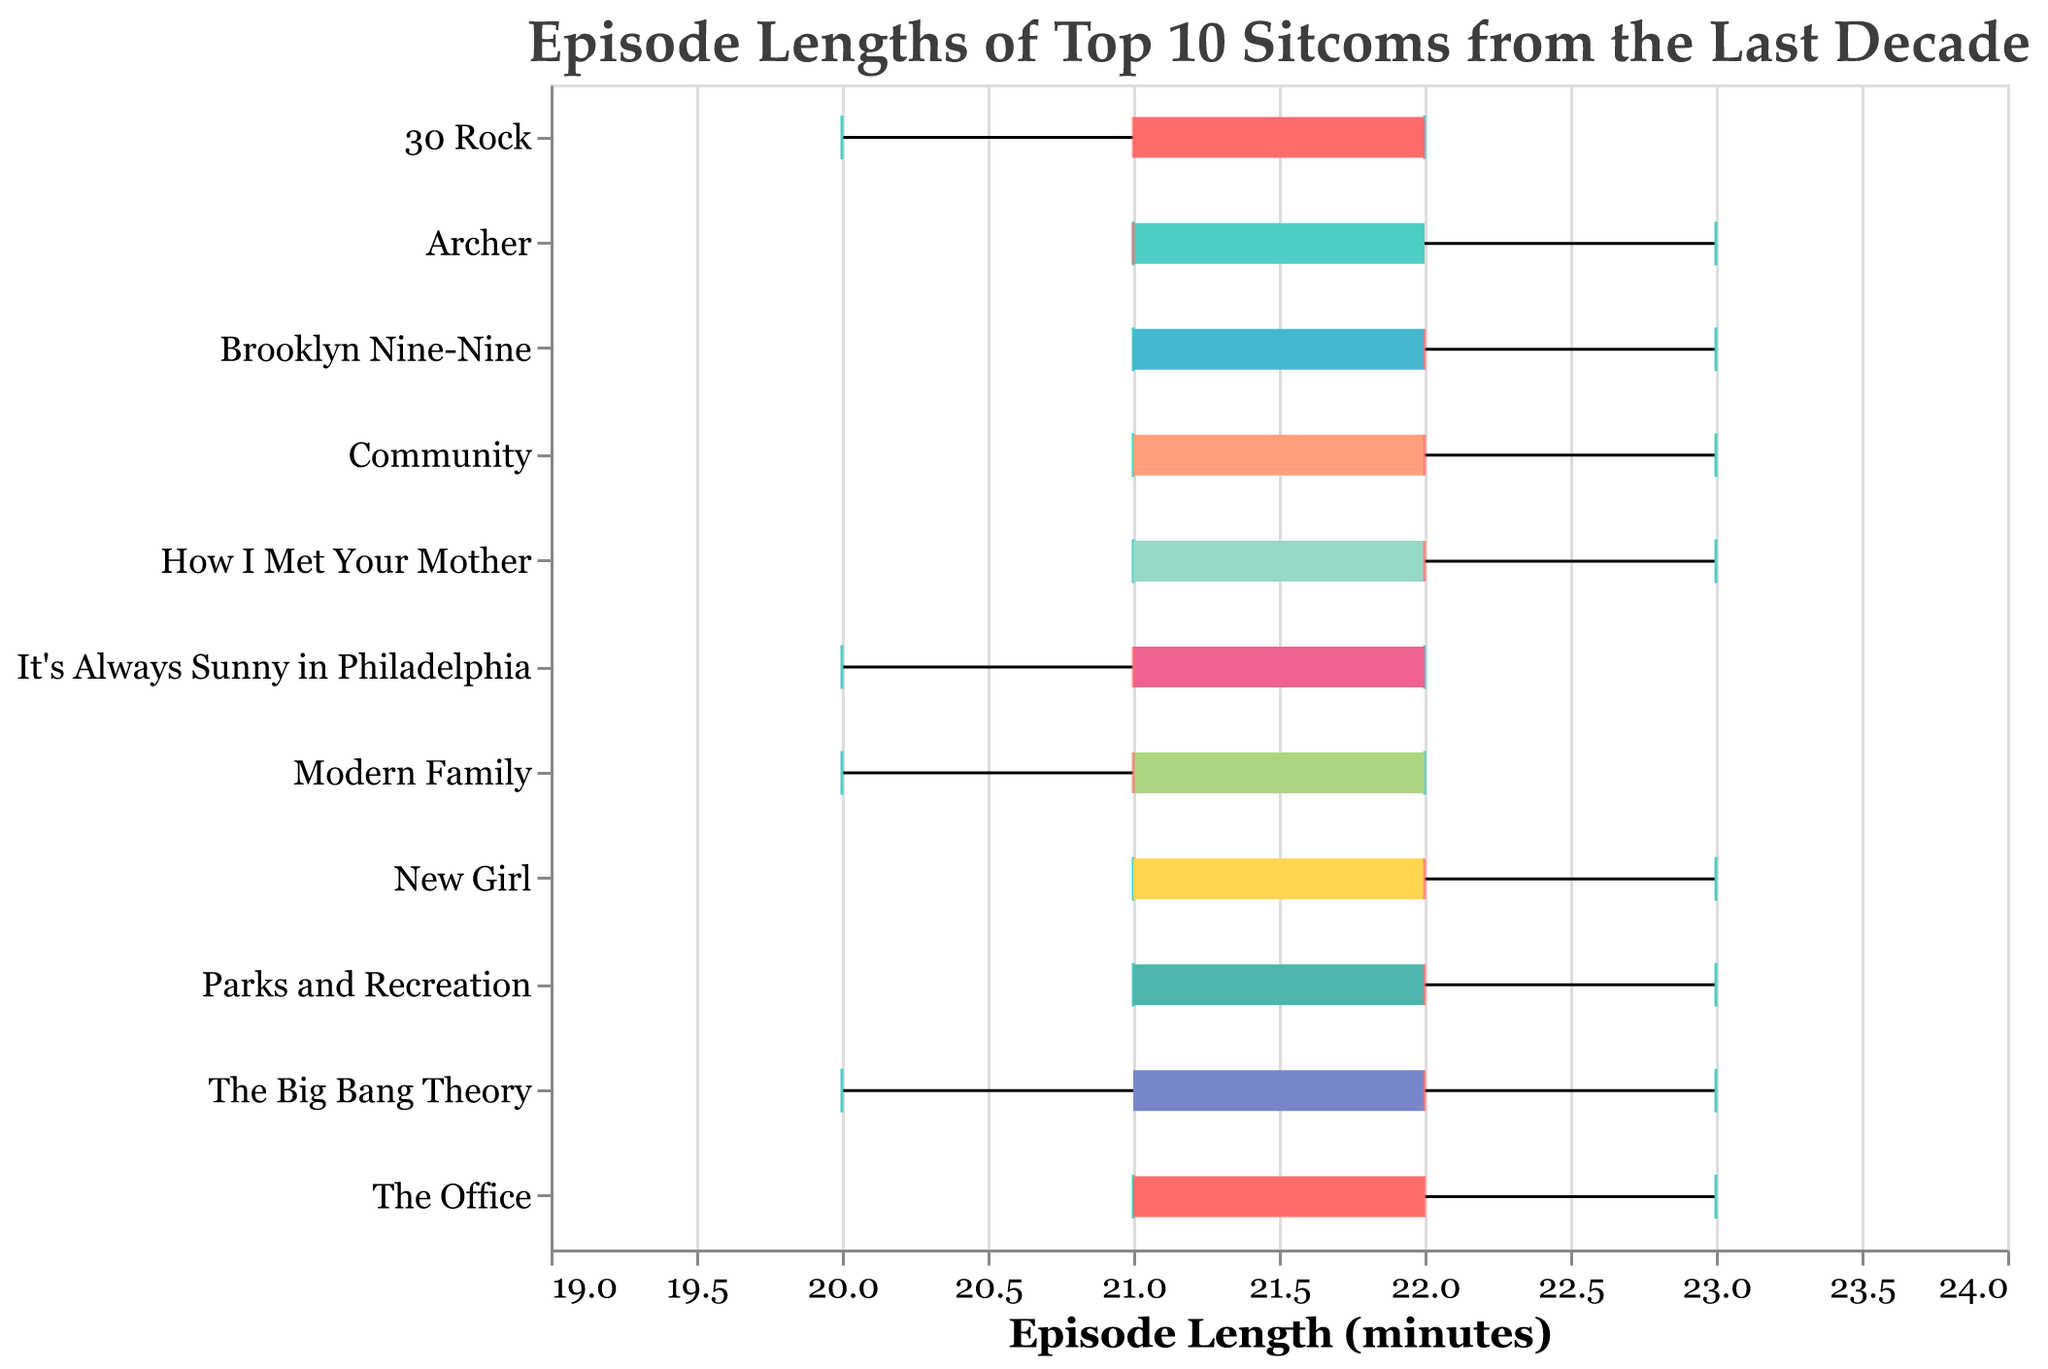What is the title of the figure? The title is located at the top of the plot in a larger font size and usually gives a summary of the visualized data. Here it reads, "Episode Lengths of Top 10 Sitcoms from the Last Decade."
Answer: Episode Lengths of Top 10 Sitcoms from the Last Decade What is the range of episode lengths for The Big Bang Theory? The minimum and maximum values are depicted by the endpoints of the boxplot's whiskers for The Big Bang Theory. The episode lengths range from 20 to 23 minutes.
Answer: 20 to 23 Which sitcom has the highest median episode length? The median is represented by a colored line within the box of each boxplot. By comparing these lines across the sitcoms, we find that several share the highest median of 22 minutes.
Answer: Multiple shows (The Big Bang Theory, Modern Family, How I Met Your Mother, etc.) How does the episode length distribution of Brooklyn Nine-Nine compare to Parks and Recreation? To compare the distributions, observe the range, median, and spread of the boxes. Both have medians around 22 minutes, but Brooklyn Nine-Nine has a slightly wider range, indicating more variability.
Answer: Similar in median but Brooklyn Nine-Nine has a wider range Which show has the smallest range of episode lengths? The range is represented by the length of the boxplot's whiskers. The show with the shortest whiskers is "The Office," covering episode lengths from 21 to 23 minutes.
Answer: The Office What are the interquartile ranges (IQR) for "New Girl"? The IQR is the range between the first quartile (lower boundary of the box) and the third quartile (upper boundary). For "New Girl," the first quartile is 21 and the third quartile is 22, making the IQR 1.
Answer: 1 Are there any outliers in the dataset based on the box plots? Outliers are points that fall outside the whiskers of the boxplots. Since all whiskers reach the minimum and maximum data points without additional separate points, there are no outliers.
Answer: No Which show has the shortest episode length in the dataset? This can be determined by finding the minimum value among all the whiskers. "Modern Family" and "It's Always Sunny in Philadelphia" both reach a minimum of 20 minutes.
Answer: Modern Family and It's Always Sunny in Philadelphia Do most sitcoms have a median episode length over 21 minutes? By evaluating the median lines within the boxes, most sitcoms show medians at or slightly above 21 minutes. Therefore, the majority have medians over 21.
Answer: Yes What is the range of episode lengths for "Archer"? Observing the boxplot for "Archer," the range is depicted by the whiskers from the minimum value of 21 to the maximum of 23.
Answer: 21 to 23 